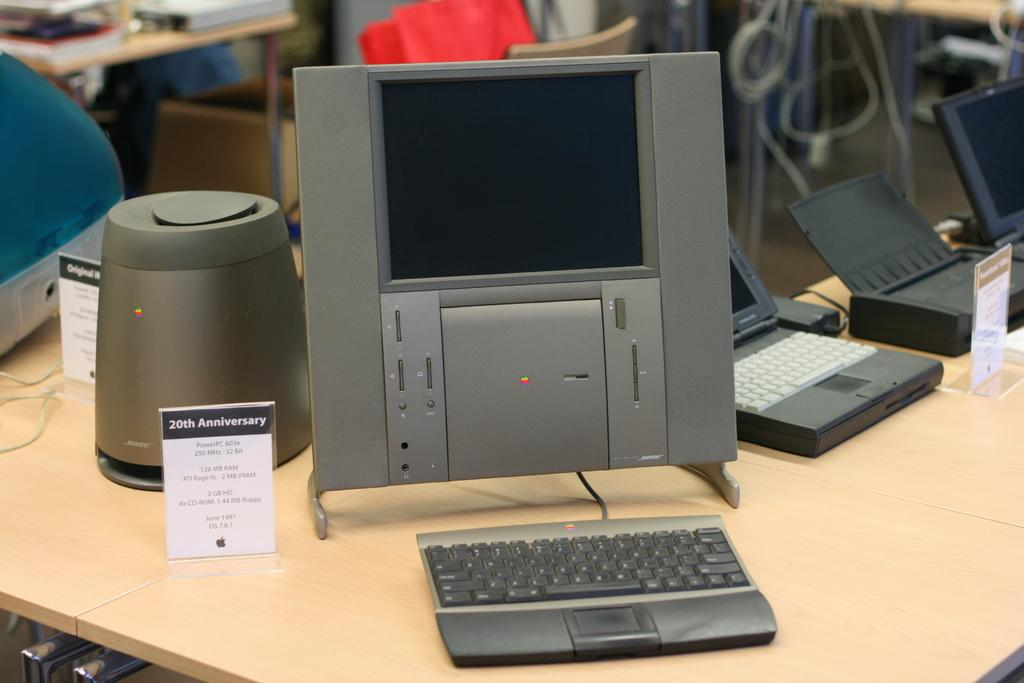<image>
Create a compact narrative representing the image presented. A small desktop PC on a table with a 20th Anniversary Bose speaker next to it 